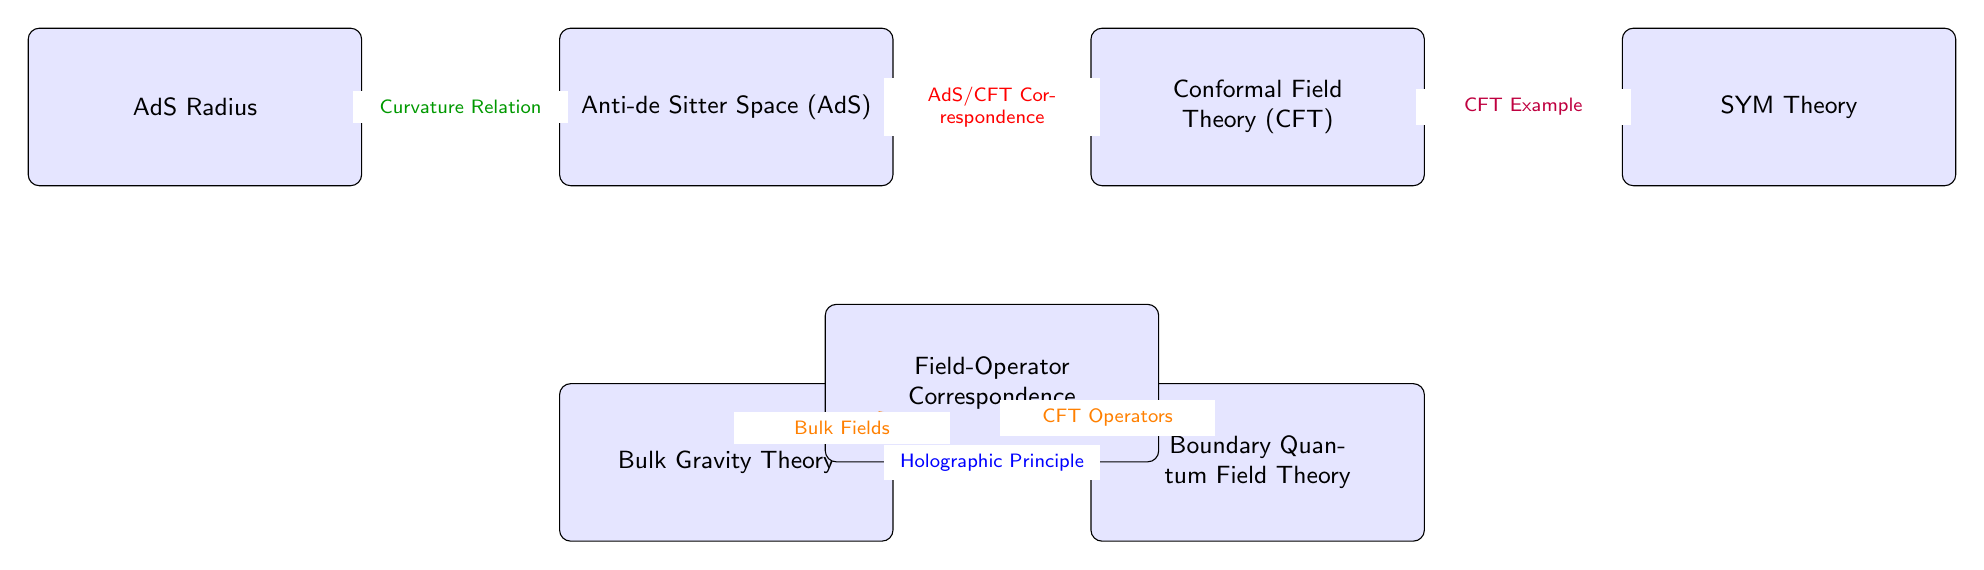What are the two main nodes linked by the red arrow? The red arrow connects the nodes "Anti-de Sitter Space (AdS)" and "Conformal Field Theory (CFT)", indicating the AdS/CFT correspondence between them.
Answer: Anti-de Sitter Space (AdS) and Conformal Field Theory (CFT) What does the blue arrow represent? The blue arrow represents the "Holographic Principle", which indicates the relationship between the "Bulk Gravity Theory" and the "Boundary Quantum Field Theory".
Answer: Holographic Principle Which node is below the "Anti-de Sitter Space (AdS)" node? The node immediately below "Anti-de Sitter Space (AdS)" is "Bulk Gravity Theory". This is a direct vertical connection in the diagram.
Answer: Bulk Gravity Theory How many nodes are there in the diagram? To find the total number of nodes, I count each labeled box: AdS, CFT, Bulk Gravity Theory, Boundary Quantum Field Theory, AdS Radius, Field-Operator Correspondence, and SYM Theory, leading to a total of 7 nodes.
Answer: 7 What theory is an example of CFT in the diagram? The diagram specifies "SYM Theory" as a CFT example. It is linked to the "Conformal Field Theory (CFT)" node by the arrow labeled as such.
Answer: SYM Theory Which two nodes are connected by the "Field-Operator Correspondence"? The "Field-Operator Correspondence" connects the "Bulk Gravity Theory" and the "Boundary Quantum Field Theory". This connection reflects the relationship between fields in the bulk and operators at the boundary.
Answer: Bulk Gravity Theory and Boundary Quantum Field Theory What mapping is indicated by the orange arrows? The orange arrows indicate the mapping of "Bulk Fields" from the "Field-Operator Correspondence" node to the "Bulk Gravity Theory" node and "CFT Operators" to the "Boundary Quantum Field Theory" node, reflecting duality.
Answer: Bulk Fields and CFT Operators What is the relationship indicated by the green arrow? The green arrow indicates a "Curvature Relation" between the "AdS Radius" and "Anti-de Sitter Space (AdS)", showing how the radius corresponds to the curvature of the AdS space.
Answer: Curvature Relation Which node is to the right of the "Conformal Field Theory (CFT)"? The node immediately to the right of "Conformal Field Theory (CFT)" is "SYM Theory". It represents an example of a CFT related to the main theory in the context of the diagram.
Answer: SYM Theory 